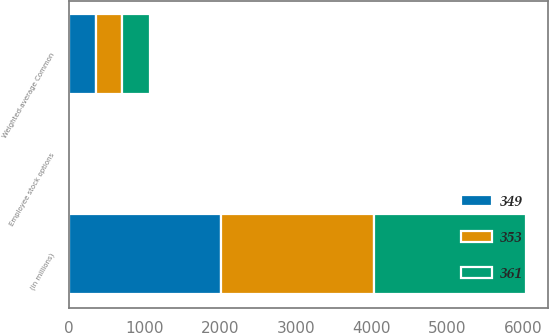Convert chart. <chart><loc_0><loc_0><loc_500><loc_500><stacked_bar_chart><ecel><fcel>(in millions)<fcel>Weighted-average Common<fcel>Employee stock options<nl><fcel>349<fcel>2012<fcel>349<fcel>4<nl><fcel>353<fcel>2011<fcel>353<fcel>4<nl><fcel>361<fcel>2010<fcel>361<fcel>2<nl></chart> 